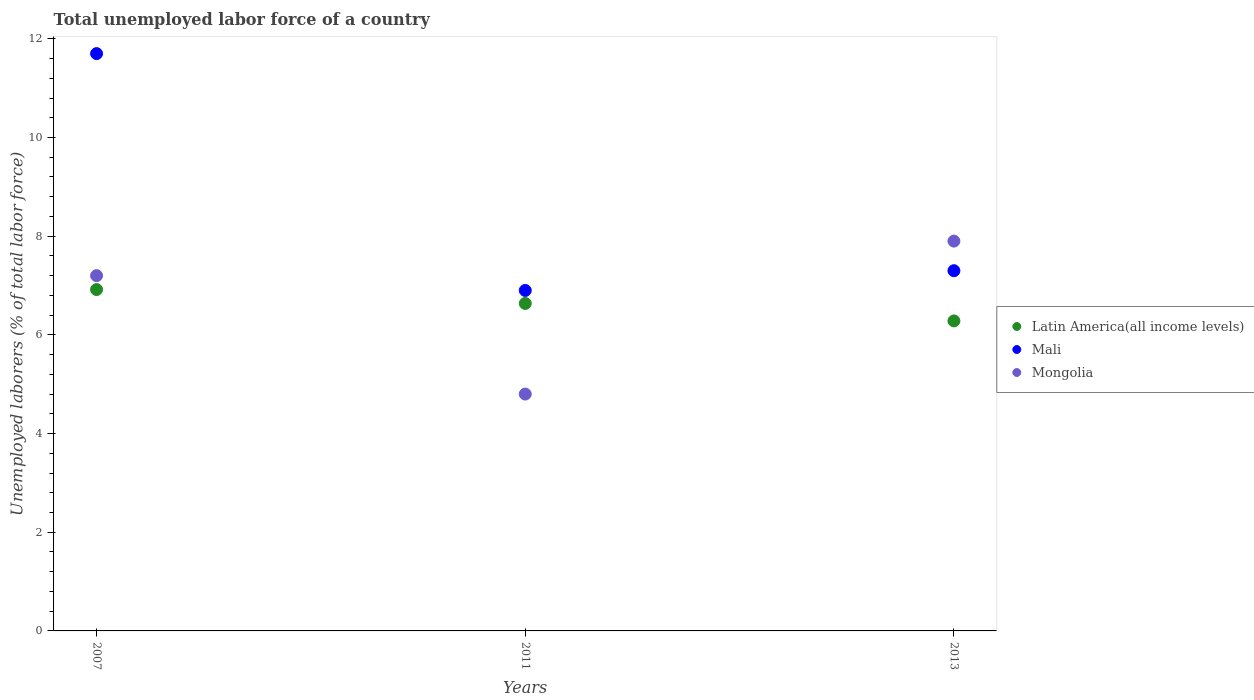Is the number of dotlines equal to the number of legend labels?
Keep it short and to the point. Yes. What is the total unemployed labor force in Mali in 2011?
Provide a short and direct response. 6.9. Across all years, what is the maximum total unemployed labor force in Mongolia?
Your answer should be compact. 7.9. Across all years, what is the minimum total unemployed labor force in Latin America(all income levels)?
Your answer should be compact. 6.28. In which year was the total unemployed labor force in Mali maximum?
Your answer should be very brief. 2007. In which year was the total unemployed labor force in Latin America(all income levels) minimum?
Your answer should be very brief. 2013. What is the total total unemployed labor force in Mali in the graph?
Offer a very short reply. 25.9. What is the difference between the total unemployed labor force in Mongolia in 2007 and that in 2011?
Offer a very short reply. 2.4. What is the difference between the total unemployed labor force in Latin America(all income levels) in 2011 and the total unemployed labor force in Mongolia in 2007?
Offer a terse response. -0.56. What is the average total unemployed labor force in Latin America(all income levels) per year?
Offer a terse response. 6.61. In the year 2011, what is the difference between the total unemployed labor force in Mali and total unemployed labor force in Mongolia?
Ensure brevity in your answer.  2.1. What is the ratio of the total unemployed labor force in Mongolia in 2011 to that in 2013?
Make the answer very short. 0.61. Is the difference between the total unemployed labor force in Mali in 2007 and 2013 greater than the difference between the total unemployed labor force in Mongolia in 2007 and 2013?
Make the answer very short. Yes. What is the difference between the highest and the second highest total unemployed labor force in Mali?
Make the answer very short. 4.4. What is the difference between the highest and the lowest total unemployed labor force in Latin America(all income levels)?
Make the answer very short. 0.63. In how many years, is the total unemployed labor force in Mongolia greater than the average total unemployed labor force in Mongolia taken over all years?
Provide a short and direct response. 2. Is the sum of the total unemployed labor force in Latin America(all income levels) in 2007 and 2011 greater than the maximum total unemployed labor force in Mali across all years?
Give a very brief answer. Yes. Is it the case that in every year, the sum of the total unemployed labor force in Mongolia and total unemployed labor force in Latin America(all income levels)  is greater than the total unemployed labor force in Mali?
Your answer should be very brief. Yes. Is the total unemployed labor force in Latin America(all income levels) strictly greater than the total unemployed labor force in Mali over the years?
Your response must be concise. No. How many dotlines are there?
Your answer should be very brief. 3. What is the difference between two consecutive major ticks on the Y-axis?
Keep it short and to the point. 2. What is the title of the graph?
Give a very brief answer. Total unemployed labor force of a country. Does "Barbados" appear as one of the legend labels in the graph?
Give a very brief answer. No. What is the label or title of the Y-axis?
Your answer should be compact. Unemployed laborers (% of total labor force). What is the Unemployed laborers (% of total labor force) of Latin America(all income levels) in 2007?
Your response must be concise. 6.92. What is the Unemployed laborers (% of total labor force) of Mali in 2007?
Provide a succinct answer. 11.7. What is the Unemployed laborers (% of total labor force) in Mongolia in 2007?
Provide a succinct answer. 7.2. What is the Unemployed laborers (% of total labor force) in Latin America(all income levels) in 2011?
Make the answer very short. 6.64. What is the Unemployed laborers (% of total labor force) in Mali in 2011?
Give a very brief answer. 6.9. What is the Unemployed laborers (% of total labor force) of Mongolia in 2011?
Provide a succinct answer. 4.8. What is the Unemployed laborers (% of total labor force) in Latin America(all income levels) in 2013?
Make the answer very short. 6.28. What is the Unemployed laborers (% of total labor force) in Mali in 2013?
Your answer should be compact. 7.3. What is the Unemployed laborers (% of total labor force) in Mongolia in 2013?
Your answer should be compact. 7.9. Across all years, what is the maximum Unemployed laborers (% of total labor force) in Latin America(all income levels)?
Keep it short and to the point. 6.92. Across all years, what is the maximum Unemployed laborers (% of total labor force) of Mali?
Your response must be concise. 11.7. Across all years, what is the maximum Unemployed laborers (% of total labor force) of Mongolia?
Your response must be concise. 7.9. Across all years, what is the minimum Unemployed laborers (% of total labor force) of Latin America(all income levels)?
Give a very brief answer. 6.28. Across all years, what is the minimum Unemployed laborers (% of total labor force) in Mali?
Provide a succinct answer. 6.9. Across all years, what is the minimum Unemployed laborers (% of total labor force) in Mongolia?
Your answer should be very brief. 4.8. What is the total Unemployed laborers (% of total labor force) of Latin America(all income levels) in the graph?
Offer a terse response. 19.84. What is the total Unemployed laborers (% of total labor force) in Mali in the graph?
Provide a short and direct response. 25.9. What is the difference between the Unemployed laborers (% of total labor force) of Latin America(all income levels) in 2007 and that in 2011?
Ensure brevity in your answer.  0.28. What is the difference between the Unemployed laborers (% of total labor force) of Mali in 2007 and that in 2011?
Keep it short and to the point. 4.8. What is the difference between the Unemployed laborers (% of total labor force) of Mongolia in 2007 and that in 2011?
Ensure brevity in your answer.  2.4. What is the difference between the Unemployed laborers (% of total labor force) of Latin America(all income levels) in 2007 and that in 2013?
Offer a terse response. 0.64. What is the difference between the Unemployed laborers (% of total labor force) of Mali in 2007 and that in 2013?
Your answer should be compact. 4.4. What is the difference between the Unemployed laborers (% of total labor force) in Mongolia in 2007 and that in 2013?
Offer a terse response. -0.7. What is the difference between the Unemployed laborers (% of total labor force) of Latin America(all income levels) in 2011 and that in 2013?
Make the answer very short. 0.35. What is the difference between the Unemployed laborers (% of total labor force) of Latin America(all income levels) in 2007 and the Unemployed laborers (% of total labor force) of Mali in 2011?
Offer a very short reply. 0.02. What is the difference between the Unemployed laborers (% of total labor force) in Latin America(all income levels) in 2007 and the Unemployed laborers (% of total labor force) in Mongolia in 2011?
Your answer should be compact. 2.12. What is the difference between the Unemployed laborers (% of total labor force) of Latin America(all income levels) in 2007 and the Unemployed laborers (% of total labor force) of Mali in 2013?
Provide a succinct answer. -0.38. What is the difference between the Unemployed laborers (% of total labor force) in Latin America(all income levels) in 2007 and the Unemployed laborers (% of total labor force) in Mongolia in 2013?
Your answer should be very brief. -0.98. What is the difference between the Unemployed laborers (% of total labor force) in Mali in 2007 and the Unemployed laborers (% of total labor force) in Mongolia in 2013?
Your response must be concise. 3.8. What is the difference between the Unemployed laborers (% of total labor force) of Latin America(all income levels) in 2011 and the Unemployed laborers (% of total labor force) of Mali in 2013?
Your response must be concise. -0.66. What is the difference between the Unemployed laborers (% of total labor force) in Latin America(all income levels) in 2011 and the Unemployed laborers (% of total labor force) in Mongolia in 2013?
Make the answer very short. -1.26. What is the difference between the Unemployed laborers (% of total labor force) of Mali in 2011 and the Unemployed laborers (% of total labor force) of Mongolia in 2013?
Keep it short and to the point. -1. What is the average Unemployed laborers (% of total labor force) in Latin America(all income levels) per year?
Make the answer very short. 6.61. What is the average Unemployed laborers (% of total labor force) of Mali per year?
Your response must be concise. 8.63. What is the average Unemployed laborers (% of total labor force) of Mongolia per year?
Your response must be concise. 6.63. In the year 2007, what is the difference between the Unemployed laborers (% of total labor force) in Latin America(all income levels) and Unemployed laborers (% of total labor force) in Mali?
Keep it short and to the point. -4.78. In the year 2007, what is the difference between the Unemployed laborers (% of total labor force) in Latin America(all income levels) and Unemployed laborers (% of total labor force) in Mongolia?
Your response must be concise. -0.28. In the year 2011, what is the difference between the Unemployed laborers (% of total labor force) in Latin America(all income levels) and Unemployed laborers (% of total labor force) in Mali?
Your answer should be compact. -0.26. In the year 2011, what is the difference between the Unemployed laborers (% of total labor force) in Latin America(all income levels) and Unemployed laborers (% of total labor force) in Mongolia?
Offer a very short reply. 1.84. In the year 2011, what is the difference between the Unemployed laborers (% of total labor force) of Mali and Unemployed laborers (% of total labor force) of Mongolia?
Offer a very short reply. 2.1. In the year 2013, what is the difference between the Unemployed laborers (% of total labor force) in Latin America(all income levels) and Unemployed laborers (% of total labor force) in Mali?
Keep it short and to the point. -1.02. In the year 2013, what is the difference between the Unemployed laborers (% of total labor force) in Latin America(all income levels) and Unemployed laborers (% of total labor force) in Mongolia?
Make the answer very short. -1.62. What is the ratio of the Unemployed laborers (% of total labor force) of Latin America(all income levels) in 2007 to that in 2011?
Ensure brevity in your answer.  1.04. What is the ratio of the Unemployed laborers (% of total labor force) in Mali in 2007 to that in 2011?
Keep it short and to the point. 1.7. What is the ratio of the Unemployed laborers (% of total labor force) of Latin America(all income levels) in 2007 to that in 2013?
Ensure brevity in your answer.  1.1. What is the ratio of the Unemployed laborers (% of total labor force) of Mali in 2007 to that in 2013?
Provide a short and direct response. 1.6. What is the ratio of the Unemployed laborers (% of total labor force) in Mongolia in 2007 to that in 2013?
Your answer should be compact. 0.91. What is the ratio of the Unemployed laborers (% of total labor force) in Latin America(all income levels) in 2011 to that in 2013?
Your answer should be very brief. 1.06. What is the ratio of the Unemployed laborers (% of total labor force) in Mali in 2011 to that in 2013?
Give a very brief answer. 0.95. What is the ratio of the Unemployed laborers (% of total labor force) in Mongolia in 2011 to that in 2013?
Make the answer very short. 0.61. What is the difference between the highest and the second highest Unemployed laborers (% of total labor force) of Latin America(all income levels)?
Ensure brevity in your answer.  0.28. What is the difference between the highest and the lowest Unemployed laborers (% of total labor force) of Latin America(all income levels)?
Offer a very short reply. 0.64. What is the difference between the highest and the lowest Unemployed laborers (% of total labor force) of Mongolia?
Provide a short and direct response. 3.1. 